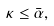<formula> <loc_0><loc_0><loc_500><loc_500>\kappa \leq \bar { \alpha } ,</formula> 